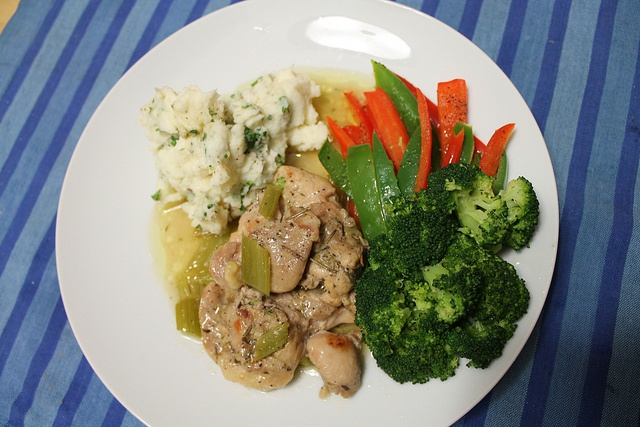Describe the objects in this image and their specific colors. I can see dining table in tan, gray, darkblue, and black tones, broccoli in tan, black, darkgreen, and olive tones, carrot in tan, red, and brown tones, carrot in tan, red, and brown tones, and carrot in tan, red, and brown tones in this image. 